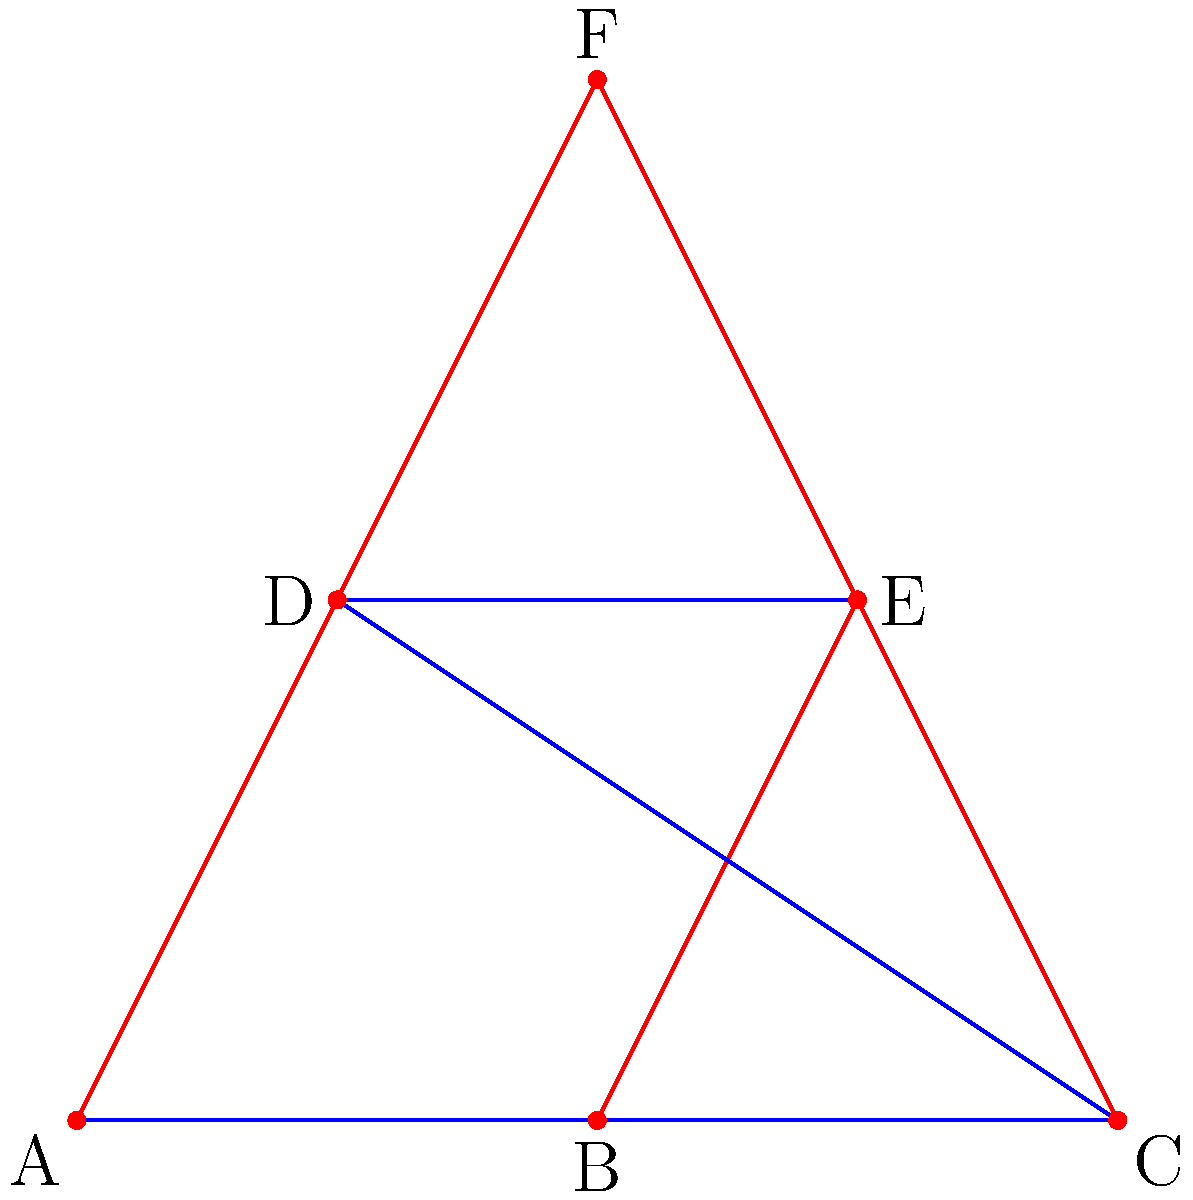The structural support system of a high-rise building is represented by the graph above, where vertices represent key structural points and edges represent support beams. Blue edges represent horizontal beams, and red edges represent vertical or diagonal beams. If the minimum number of beams that need to be intact for the building to maintain its structural integrity is 7, what is the maximum number of beams that can fail before the building's integrity is compromised? To solve this problem, we need to follow these steps:

1. Count the total number of beams (edges) in the graph:
   - There are 3 blue horizontal beams
   - There are 6 red vertical or diagonal beams
   - Total beams = 3 + 6 = 9

2. Determine the number of beams that need to remain intact:
   - The question states that a minimum of 7 beams need to be intact

3. Calculate the maximum number of beams that can fail:
   - Maximum failing beams = Total beams - Minimum intact beams
   - Maximum failing beams = 9 - 7 = 2

Therefore, a maximum of 2 beams can fail before the building's structural integrity is compromised.
Answer: 2 beams 